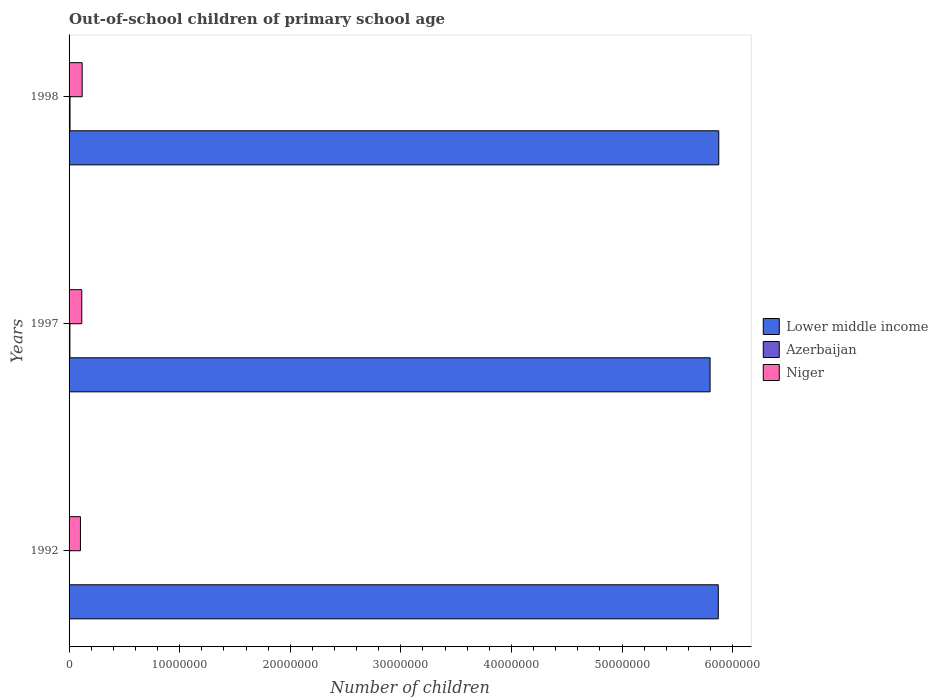How many different coloured bars are there?
Give a very brief answer. 3. Are the number of bars on each tick of the Y-axis equal?
Offer a very short reply. Yes. In how many cases, is the number of bars for a given year not equal to the number of legend labels?
Your answer should be very brief. 0. What is the number of out-of-school children in Azerbaijan in 1997?
Your answer should be compact. 7.44e+04. Across all years, what is the maximum number of out-of-school children in Azerbaijan?
Your answer should be compact. 8.48e+04. Across all years, what is the minimum number of out-of-school children in Lower middle income?
Give a very brief answer. 5.80e+07. In which year was the number of out-of-school children in Azerbaijan minimum?
Give a very brief answer. 1992. What is the total number of out-of-school children in Azerbaijan in the graph?
Give a very brief answer. 1.96e+05. What is the difference between the number of out-of-school children in Lower middle income in 1997 and that in 1998?
Your response must be concise. -7.86e+05. What is the difference between the number of out-of-school children in Azerbaijan in 1992 and the number of out-of-school children in Lower middle income in 1998?
Provide a succinct answer. -5.87e+07. What is the average number of out-of-school children in Azerbaijan per year?
Provide a short and direct response. 6.54e+04. In the year 1998, what is the difference between the number of out-of-school children in Niger and number of out-of-school children in Lower middle income?
Give a very brief answer. -5.76e+07. What is the ratio of the number of out-of-school children in Niger in 1997 to that in 1998?
Give a very brief answer. 0.97. What is the difference between the highest and the second highest number of out-of-school children in Azerbaijan?
Ensure brevity in your answer.  1.04e+04. What is the difference between the highest and the lowest number of out-of-school children in Lower middle income?
Provide a short and direct response. 7.86e+05. In how many years, is the number of out-of-school children in Lower middle income greater than the average number of out-of-school children in Lower middle income taken over all years?
Provide a short and direct response. 2. Is the sum of the number of out-of-school children in Niger in 1992 and 1998 greater than the maximum number of out-of-school children in Lower middle income across all years?
Your response must be concise. No. What does the 3rd bar from the top in 1997 represents?
Ensure brevity in your answer.  Lower middle income. What does the 1st bar from the bottom in 1997 represents?
Ensure brevity in your answer.  Lower middle income. Are all the bars in the graph horizontal?
Ensure brevity in your answer.  Yes. What is the difference between two consecutive major ticks on the X-axis?
Make the answer very short. 1.00e+07. Are the values on the major ticks of X-axis written in scientific E-notation?
Your answer should be very brief. No. Does the graph contain grids?
Ensure brevity in your answer.  No. How many legend labels are there?
Your answer should be compact. 3. What is the title of the graph?
Provide a short and direct response. Out-of-school children of primary school age. Does "Small states" appear as one of the legend labels in the graph?
Offer a very short reply. No. What is the label or title of the X-axis?
Make the answer very short. Number of children. What is the Number of children in Lower middle income in 1992?
Your response must be concise. 5.87e+07. What is the Number of children in Azerbaijan in 1992?
Your answer should be very brief. 3.70e+04. What is the Number of children in Niger in 1992?
Give a very brief answer. 1.03e+06. What is the Number of children of Lower middle income in 1997?
Ensure brevity in your answer.  5.80e+07. What is the Number of children of Azerbaijan in 1997?
Provide a short and direct response. 7.44e+04. What is the Number of children in Niger in 1997?
Offer a very short reply. 1.15e+06. What is the Number of children in Lower middle income in 1998?
Provide a succinct answer. 5.87e+07. What is the Number of children in Azerbaijan in 1998?
Offer a very short reply. 8.48e+04. What is the Number of children in Niger in 1998?
Provide a succinct answer. 1.18e+06. Across all years, what is the maximum Number of children of Lower middle income?
Offer a terse response. 5.87e+07. Across all years, what is the maximum Number of children in Azerbaijan?
Keep it short and to the point. 8.48e+04. Across all years, what is the maximum Number of children of Niger?
Give a very brief answer. 1.18e+06. Across all years, what is the minimum Number of children of Lower middle income?
Your answer should be very brief. 5.80e+07. Across all years, what is the minimum Number of children in Azerbaijan?
Provide a succinct answer. 3.70e+04. Across all years, what is the minimum Number of children in Niger?
Give a very brief answer. 1.03e+06. What is the total Number of children of Lower middle income in the graph?
Provide a short and direct response. 1.75e+08. What is the total Number of children in Azerbaijan in the graph?
Ensure brevity in your answer.  1.96e+05. What is the total Number of children of Niger in the graph?
Offer a terse response. 3.36e+06. What is the difference between the Number of children in Lower middle income in 1992 and that in 1997?
Keep it short and to the point. 7.42e+05. What is the difference between the Number of children of Azerbaijan in 1992 and that in 1997?
Ensure brevity in your answer.  -3.73e+04. What is the difference between the Number of children in Niger in 1992 and that in 1997?
Keep it short and to the point. -1.21e+05. What is the difference between the Number of children in Lower middle income in 1992 and that in 1998?
Offer a terse response. -4.45e+04. What is the difference between the Number of children in Azerbaijan in 1992 and that in 1998?
Give a very brief answer. -4.78e+04. What is the difference between the Number of children in Niger in 1992 and that in 1998?
Your answer should be very brief. -1.56e+05. What is the difference between the Number of children of Lower middle income in 1997 and that in 1998?
Give a very brief answer. -7.86e+05. What is the difference between the Number of children of Azerbaijan in 1997 and that in 1998?
Your answer should be very brief. -1.04e+04. What is the difference between the Number of children of Niger in 1997 and that in 1998?
Give a very brief answer. -3.54e+04. What is the difference between the Number of children in Lower middle income in 1992 and the Number of children in Azerbaijan in 1997?
Your answer should be very brief. 5.86e+07. What is the difference between the Number of children of Lower middle income in 1992 and the Number of children of Niger in 1997?
Make the answer very short. 5.76e+07. What is the difference between the Number of children of Azerbaijan in 1992 and the Number of children of Niger in 1997?
Provide a succinct answer. -1.11e+06. What is the difference between the Number of children of Lower middle income in 1992 and the Number of children of Azerbaijan in 1998?
Keep it short and to the point. 5.86e+07. What is the difference between the Number of children of Lower middle income in 1992 and the Number of children of Niger in 1998?
Your response must be concise. 5.75e+07. What is the difference between the Number of children in Azerbaijan in 1992 and the Number of children in Niger in 1998?
Provide a short and direct response. -1.15e+06. What is the difference between the Number of children of Lower middle income in 1997 and the Number of children of Azerbaijan in 1998?
Make the answer very short. 5.79e+07. What is the difference between the Number of children of Lower middle income in 1997 and the Number of children of Niger in 1998?
Provide a short and direct response. 5.68e+07. What is the difference between the Number of children in Azerbaijan in 1997 and the Number of children in Niger in 1998?
Your answer should be compact. -1.11e+06. What is the average Number of children of Lower middle income per year?
Provide a short and direct response. 5.85e+07. What is the average Number of children in Azerbaijan per year?
Keep it short and to the point. 6.54e+04. What is the average Number of children of Niger per year?
Offer a very short reply. 1.12e+06. In the year 1992, what is the difference between the Number of children of Lower middle income and Number of children of Azerbaijan?
Provide a succinct answer. 5.87e+07. In the year 1992, what is the difference between the Number of children in Lower middle income and Number of children in Niger?
Provide a succinct answer. 5.77e+07. In the year 1992, what is the difference between the Number of children in Azerbaijan and Number of children in Niger?
Offer a terse response. -9.91e+05. In the year 1997, what is the difference between the Number of children of Lower middle income and Number of children of Azerbaijan?
Offer a very short reply. 5.79e+07. In the year 1997, what is the difference between the Number of children in Lower middle income and Number of children in Niger?
Keep it short and to the point. 5.68e+07. In the year 1997, what is the difference between the Number of children in Azerbaijan and Number of children in Niger?
Offer a terse response. -1.07e+06. In the year 1998, what is the difference between the Number of children of Lower middle income and Number of children of Azerbaijan?
Offer a very short reply. 5.87e+07. In the year 1998, what is the difference between the Number of children in Lower middle income and Number of children in Niger?
Your answer should be very brief. 5.76e+07. In the year 1998, what is the difference between the Number of children in Azerbaijan and Number of children in Niger?
Provide a short and direct response. -1.10e+06. What is the ratio of the Number of children of Lower middle income in 1992 to that in 1997?
Your answer should be compact. 1.01. What is the ratio of the Number of children of Azerbaijan in 1992 to that in 1997?
Your answer should be compact. 0.5. What is the ratio of the Number of children of Niger in 1992 to that in 1997?
Give a very brief answer. 0.89. What is the ratio of the Number of children in Lower middle income in 1992 to that in 1998?
Give a very brief answer. 1. What is the ratio of the Number of children in Azerbaijan in 1992 to that in 1998?
Your answer should be compact. 0.44. What is the ratio of the Number of children in Niger in 1992 to that in 1998?
Offer a very short reply. 0.87. What is the ratio of the Number of children of Lower middle income in 1997 to that in 1998?
Offer a terse response. 0.99. What is the ratio of the Number of children in Azerbaijan in 1997 to that in 1998?
Give a very brief answer. 0.88. What is the ratio of the Number of children in Niger in 1997 to that in 1998?
Your answer should be very brief. 0.97. What is the difference between the highest and the second highest Number of children of Lower middle income?
Your answer should be very brief. 4.45e+04. What is the difference between the highest and the second highest Number of children of Azerbaijan?
Keep it short and to the point. 1.04e+04. What is the difference between the highest and the second highest Number of children in Niger?
Make the answer very short. 3.54e+04. What is the difference between the highest and the lowest Number of children of Lower middle income?
Make the answer very short. 7.86e+05. What is the difference between the highest and the lowest Number of children of Azerbaijan?
Your answer should be compact. 4.78e+04. What is the difference between the highest and the lowest Number of children in Niger?
Provide a succinct answer. 1.56e+05. 